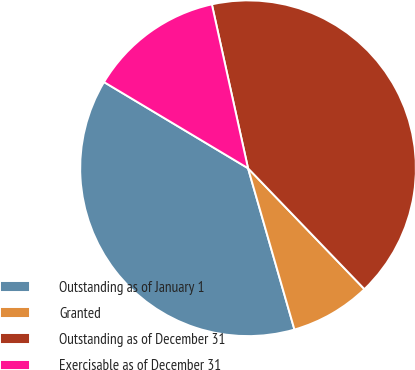Convert chart to OTSL. <chart><loc_0><loc_0><loc_500><loc_500><pie_chart><fcel>Outstanding as of January 1<fcel>Granted<fcel>Outstanding as of December 31<fcel>Exercisable as of December 31<nl><fcel>38.04%<fcel>7.74%<fcel>41.26%<fcel>12.96%<nl></chart> 